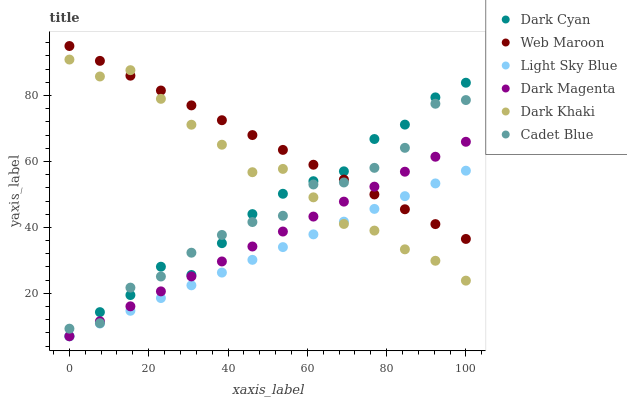Does Light Sky Blue have the minimum area under the curve?
Answer yes or no. Yes. Does Web Maroon have the maximum area under the curve?
Answer yes or no. Yes. Does Dark Magenta have the minimum area under the curve?
Answer yes or no. No. Does Dark Magenta have the maximum area under the curve?
Answer yes or no. No. Is Light Sky Blue the smoothest?
Answer yes or no. Yes. Is Cadet Blue the roughest?
Answer yes or no. Yes. Is Dark Magenta the smoothest?
Answer yes or no. No. Is Dark Magenta the roughest?
Answer yes or no. No. Does Dark Magenta have the lowest value?
Answer yes or no. Yes. Does Web Maroon have the lowest value?
Answer yes or no. No. Does Web Maroon have the highest value?
Answer yes or no. Yes. Does Dark Magenta have the highest value?
Answer yes or no. No. Is Light Sky Blue less than Cadet Blue?
Answer yes or no. Yes. Is Cadet Blue greater than Light Sky Blue?
Answer yes or no. Yes. Does Web Maroon intersect Light Sky Blue?
Answer yes or no. Yes. Is Web Maroon less than Light Sky Blue?
Answer yes or no. No. Is Web Maroon greater than Light Sky Blue?
Answer yes or no. No. Does Light Sky Blue intersect Cadet Blue?
Answer yes or no. No. 